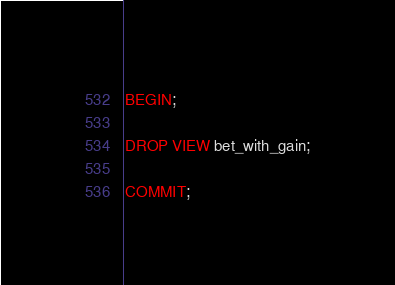Convert code to text. <code><loc_0><loc_0><loc_500><loc_500><_SQL_>BEGIN;

DROP VIEW bet_with_gain;

COMMIT;
</code> 